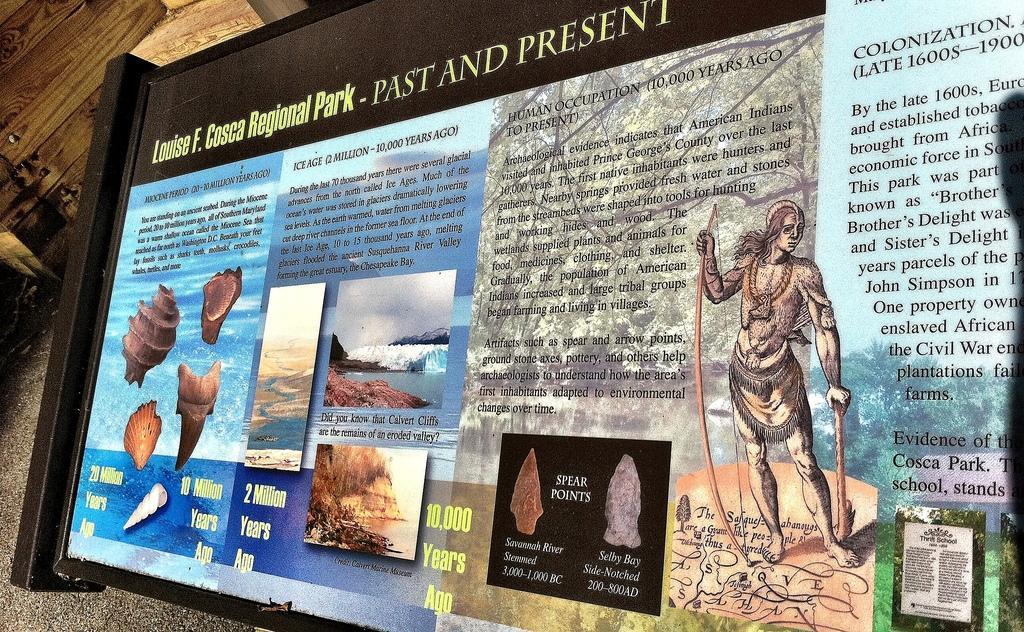Provide a one-sentence caption for the provided image. Louise F. Cosca Regional Park Past and Present information. 